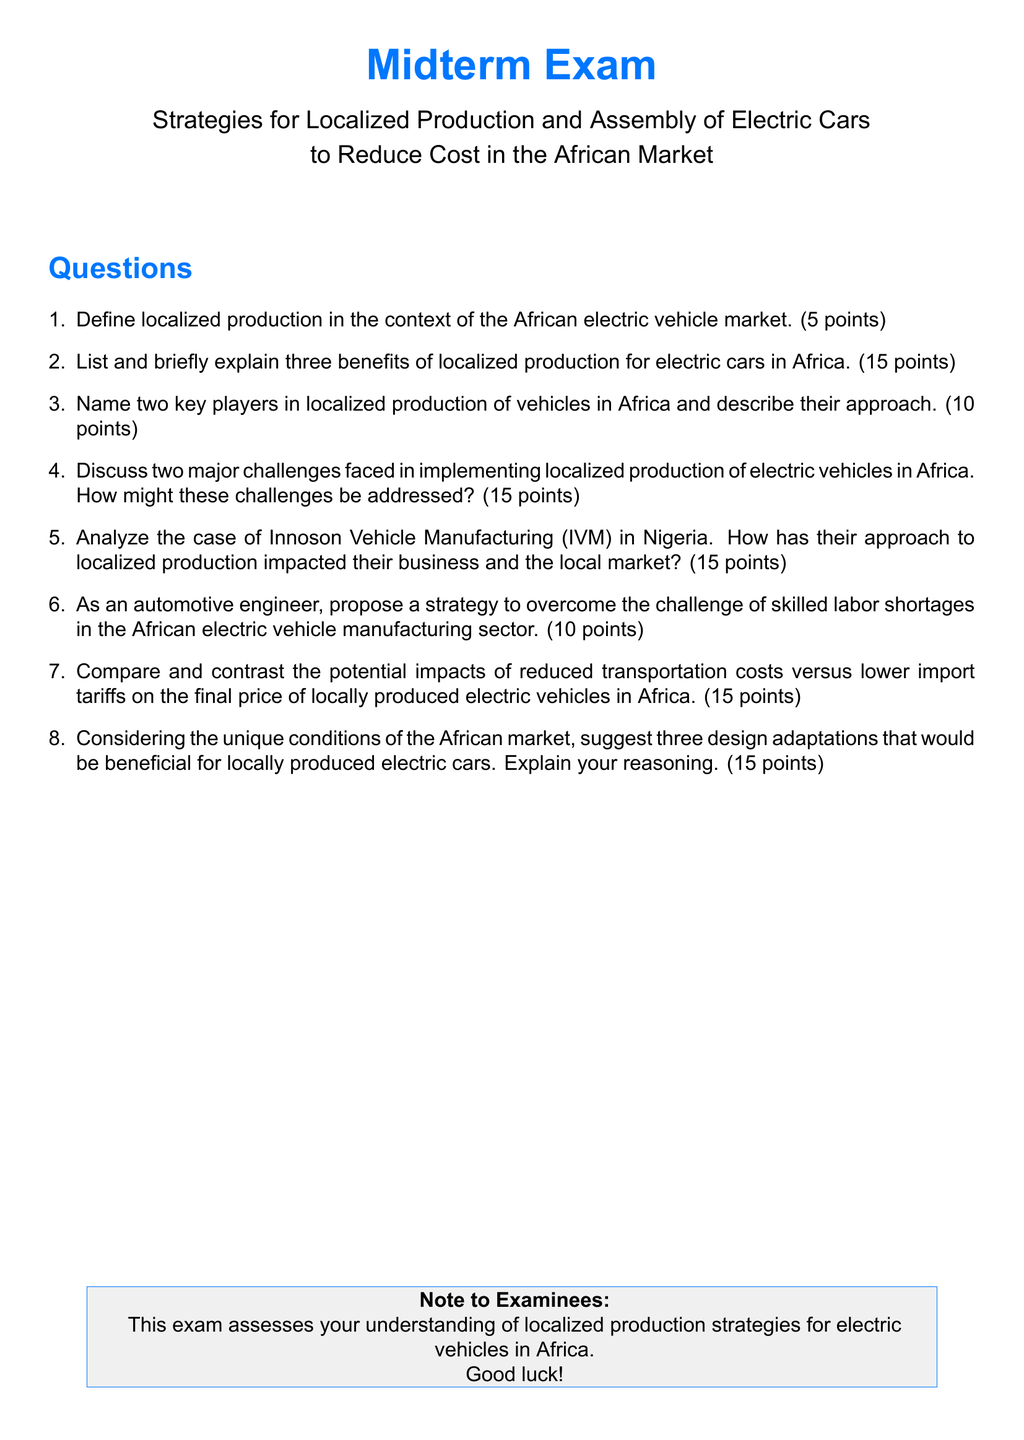What is the title of the midterm exam? The title of the midterm exam is given at the top of the document, which states "Midterm Exam" and further specifies the subject matter.
Answer: Midterm Exam How many points is the question about defined localized production worth? The document specifies that the first question is worth 5 points.
Answer: 5 points What is the total number of questions in the exam? The document lists eight questions in the enumerated section.
Answer: 8 Who is the focus case study in the exam? The case study mentioned in the exam relates to a specific vehicle manufacturer in Nigeria, known as Innoson Vehicle Manufacturing.
Answer: Innoson Vehicle Manufacturing (IVM) What are the three design adaptations mentioned for locally produced electric cars? The document prompts for suggestions on three design adaptations considering unique market conditions but doesn't specify these adaptations, inviting reasoning.
Answer: Not specified in the document How many points are allocated for the question discussing challenges in localized production? The document clearly indicates that the question regarding challenges is worth 15 points.
Answer: 15 points What color is used for the headings in the document? The headings in the document are styled with a specific RGB color called electric blue.
Answer: Electric blue What is the key theme assessed in this exam? The note to examinees outlines that the exam focuses on localized production strategies for electric vehicles in Africa.
Answer: Localized production strategies for electric vehicles in Africa 